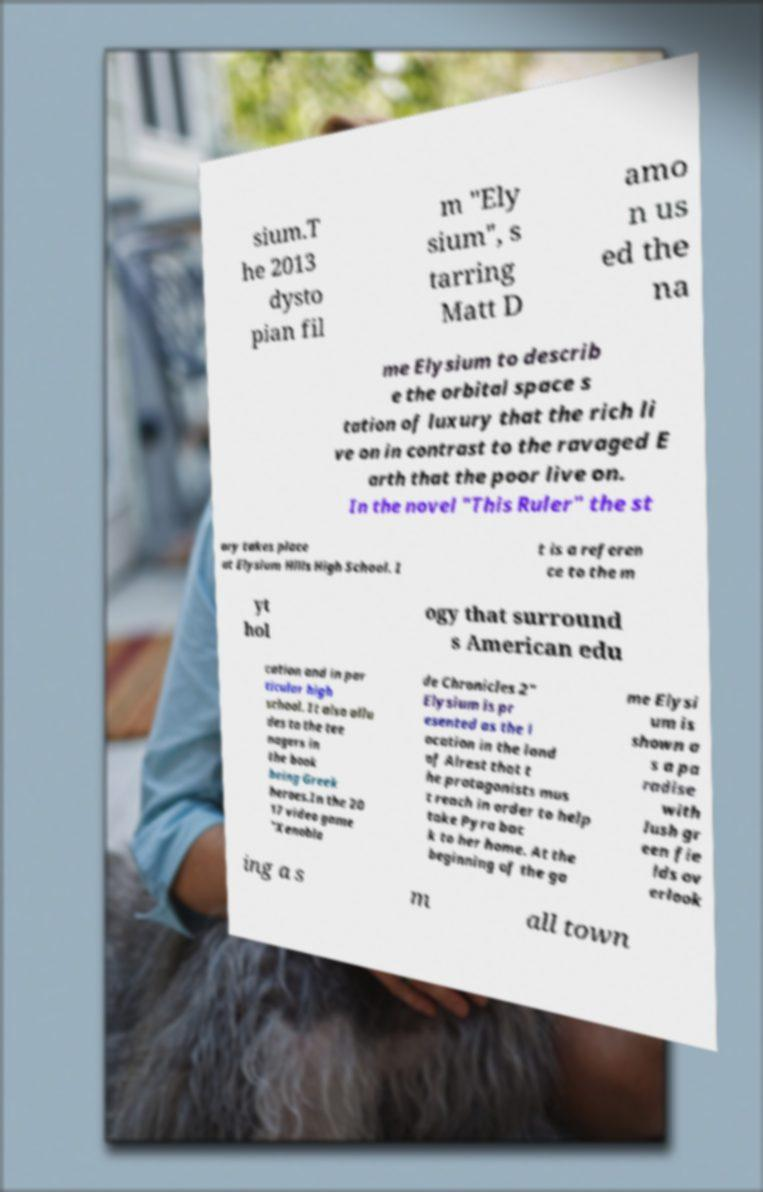Could you assist in decoding the text presented in this image and type it out clearly? sium.T he 2013 dysto pian fil m "Ely sium", s tarring Matt D amo n us ed the na me Elysium to describ e the orbital space s tation of luxury that the rich li ve on in contrast to the ravaged E arth that the poor live on. In the novel "This Ruler" the st ory takes place at Elysium Hills High School. I t is a referen ce to the m yt hol ogy that surround s American edu cation and in par ticular high school. It also allu des to the tee nagers in the book being Greek heroes.In the 20 17 video game "Xenobla de Chronicles 2" Elysium is pr esented as the l ocation in the land of Alrest that t he protagonists mus t reach in order to help take Pyra bac k to her home. At the beginning of the ga me Elysi um is shown a s a pa radise with lush gr een fie lds ov erlook ing a s m all town 